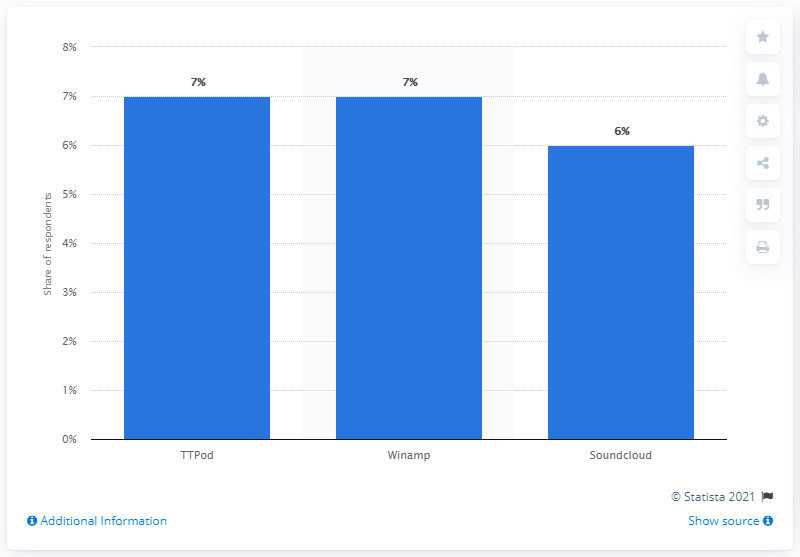Draw attention to some important aspects in this diagram. According to the survey, 6% of respondents reported using Soundcloud as their go-to app for listening to music. 